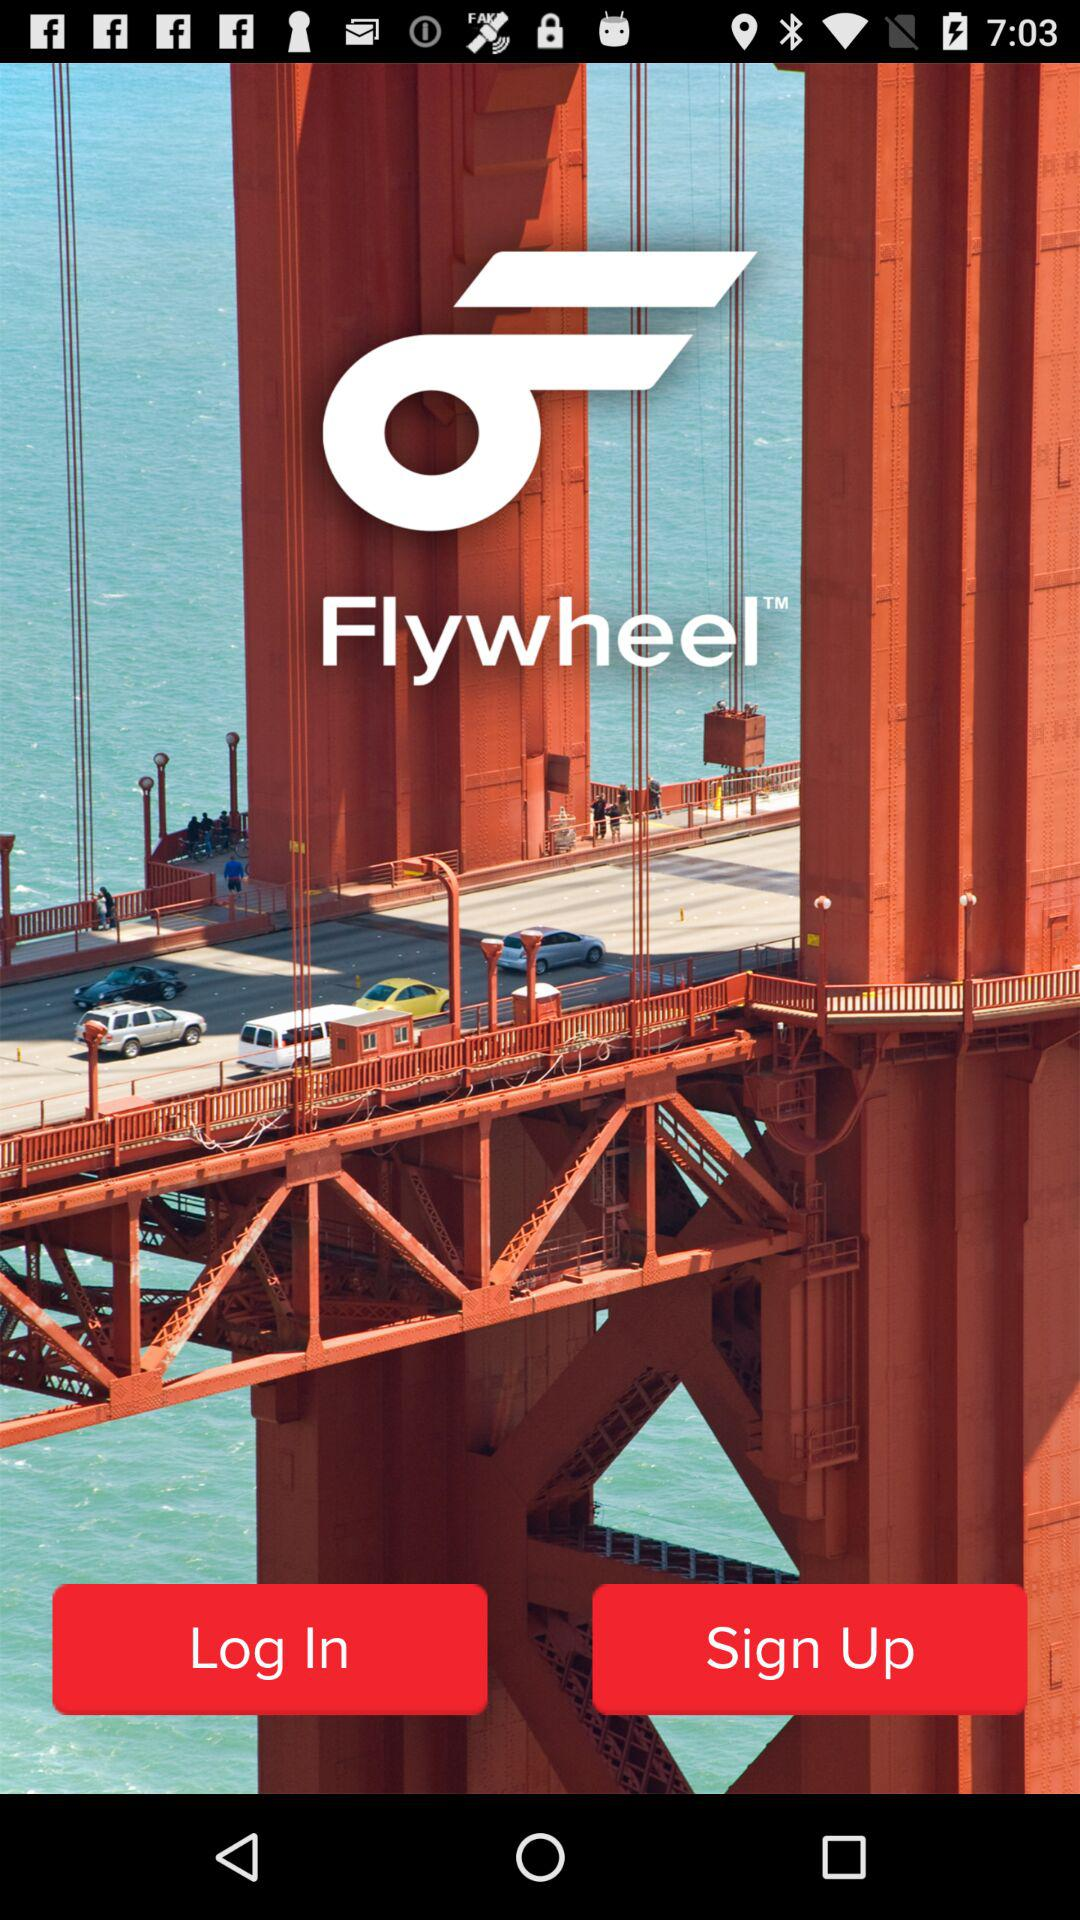What is the application name? The application name is "Flywheel". 